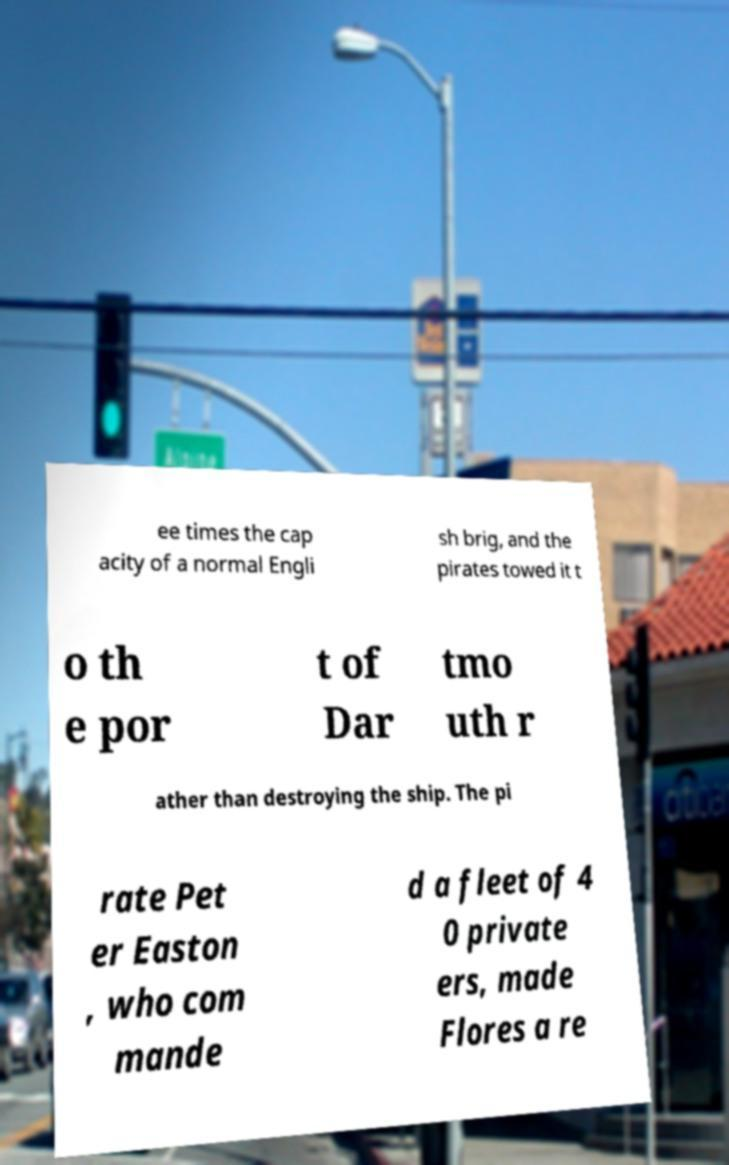Can you accurately transcribe the text from the provided image for me? ee times the cap acity of a normal Engli sh brig, and the pirates towed it t o th e por t of Dar tmo uth r ather than destroying the ship. The pi rate Pet er Easton , who com mande d a fleet of 4 0 private ers, made Flores a re 